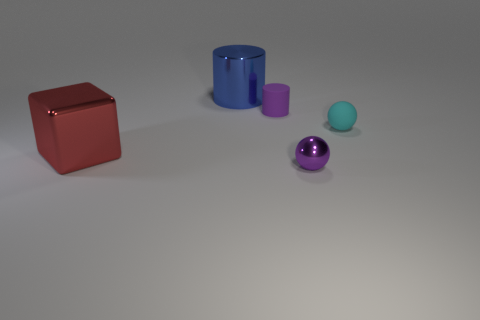There is a blue object that is the same size as the red thing; what material is it?
Provide a short and direct response. Metal. There is a rubber object to the right of the tiny purple cylinder; does it have the same size as the purple thing that is behind the cyan sphere?
Your answer should be compact. Yes. What number of things are either brown objects or things behind the big red metallic object?
Ensure brevity in your answer.  3. Is there another cyan object of the same shape as the small cyan object?
Give a very brief answer. No. There is a ball that is behind the ball in front of the big red thing; what is its size?
Make the answer very short. Small. Is the color of the tiny shiny ball the same as the small rubber ball?
Give a very brief answer. No. What number of rubber objects are red blocks or gray blocks?
Your answer should be compact. 0. How many tiny cyan rubber things are there?
Your answer should be compact. 1. Are the thing to the left of the big blue metallic cylinder and the tiny purple thing behind the small cyan sphere made of the same material?
Offer a terse response. No. What color is the other small thing that is the same shape as the cyan matte thing?
Your response must be concise. Purple. 